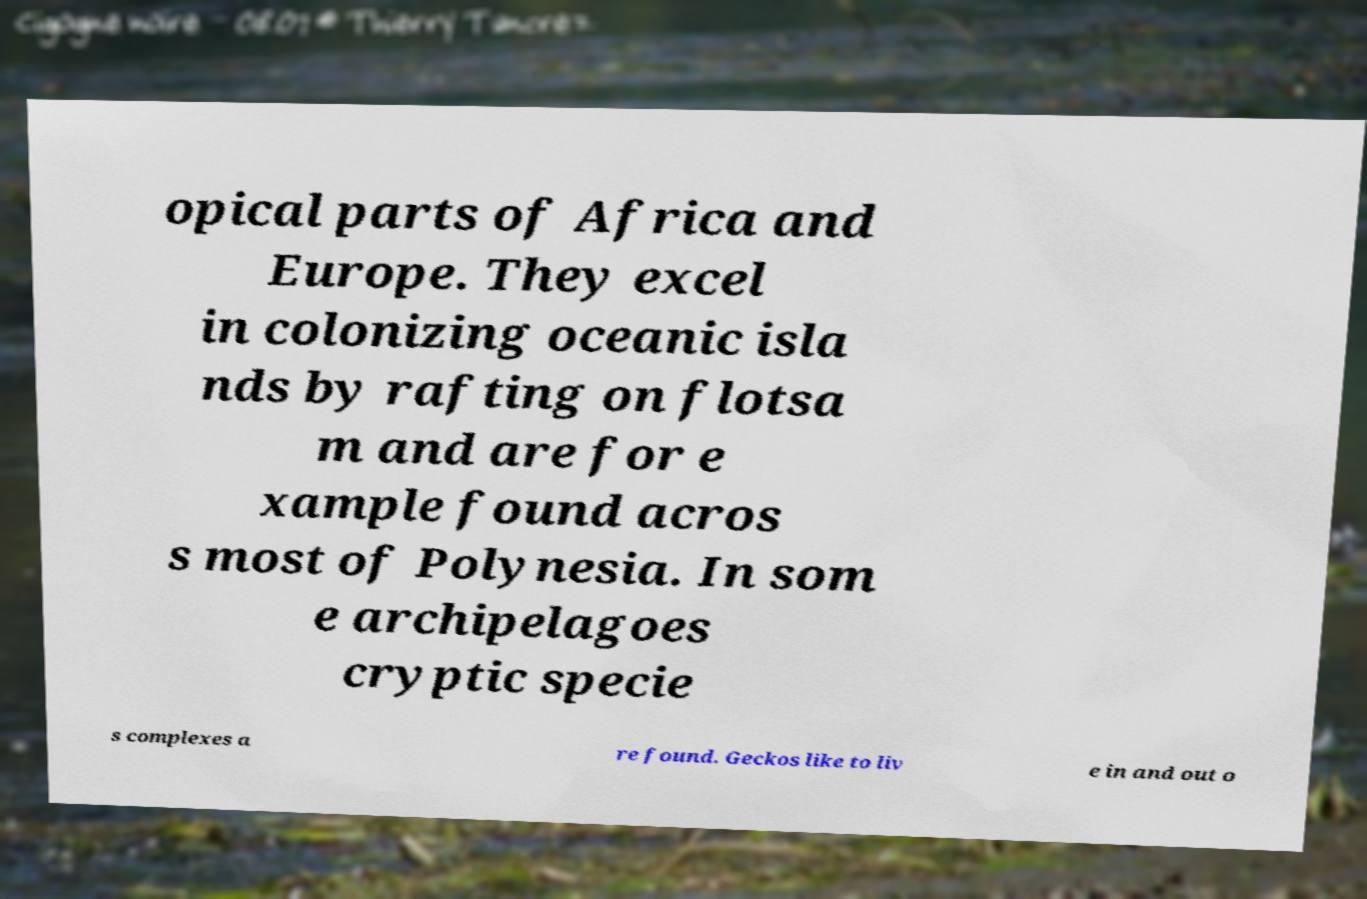There's text embedded in this image that I need extracted. Can you transcribe it verbatim? opical parts of Africa and Europe. They excel in colonizing oceanic isla nds by rafting on flotsa m and are for e xample found acros s most of Polynesia. In som e archipelagoes cryptic specie s complexes a re found. Geckos like to liv e in and out o 